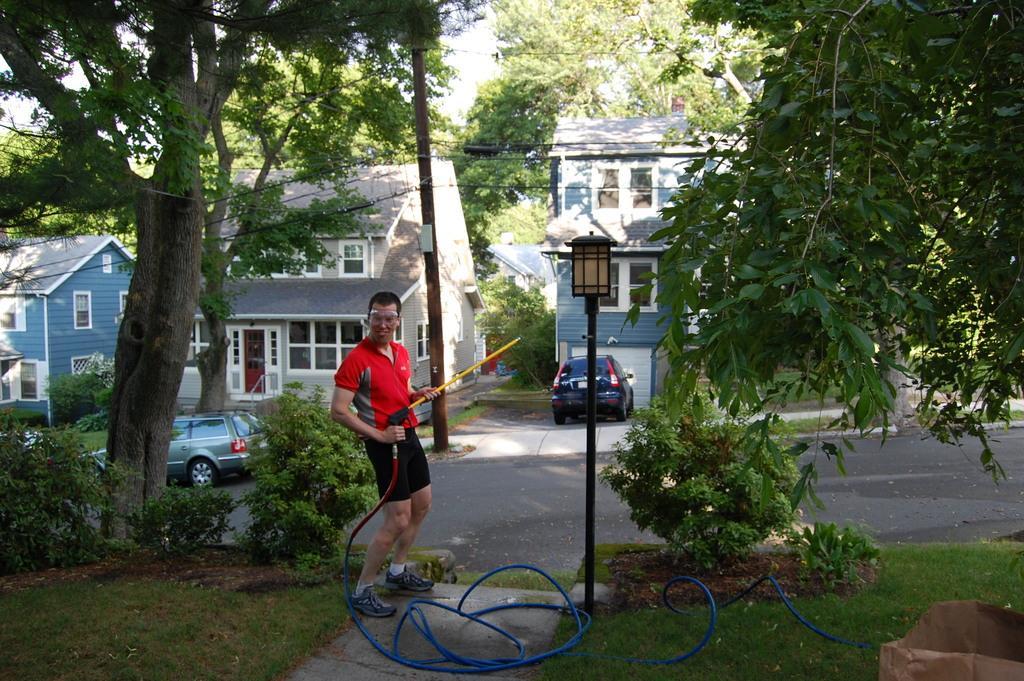Describe this image in one or two sentences. In this image there is a person standing and holding a pipe , and there is grass, plants, road, cars , houses, trees, and in the background there is sky. 